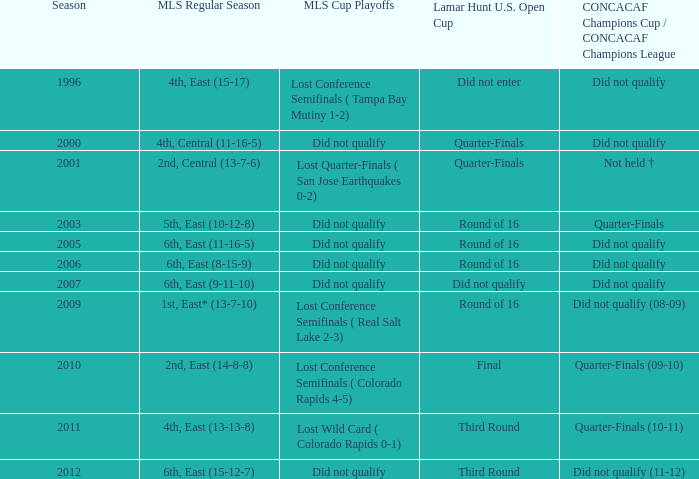In the mls regular season where the 1st place team in the east had a 13-7-10 record, how many mls cup playoffs took place? 1.0. 